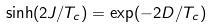<formula> <loc_0><loc_0><loc_500><loc_500>\sinh ( 2 J / T _ { c } ) = \exp ( - 2 D / T _ { c } )</formula> 